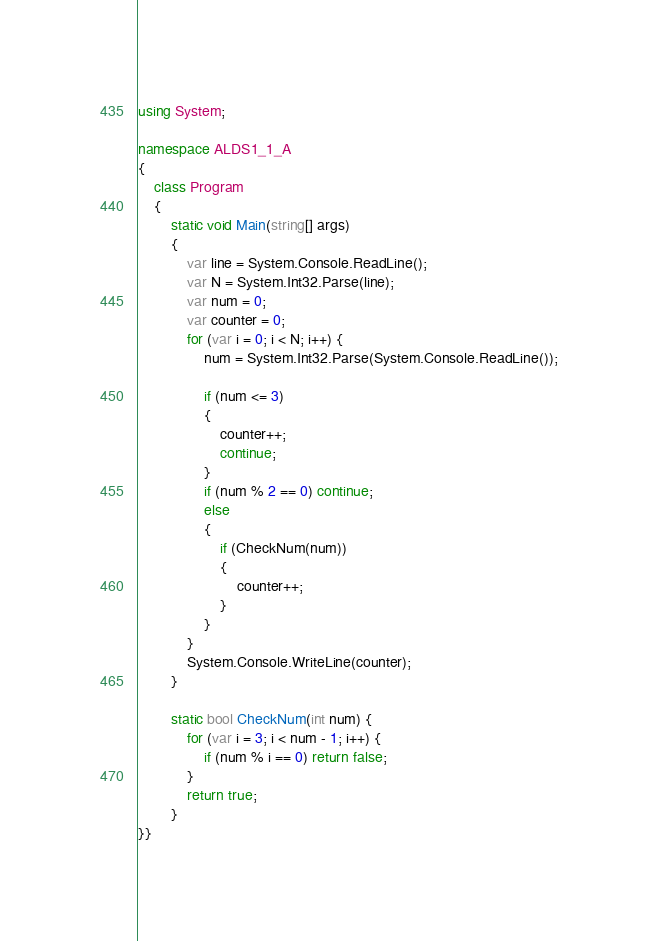Convert code to text. <code><loc_0><loc_0><loc_500><loc_500><_C#_>using System;

namespace ALDS1_1_A
{
    class Program
    {
        static void Main(string[] args)
        {
            var line = System.Console.ReadLine();
            var N = System.Int32.Parse(line);
            var num = 0;
            var counter = 0;
            for (var i = 0; i < N; i++) {
                num = System.Int32.Parse(System.Console.ReadLine());

                if (num <= 3)
                {
                    counter++;
                    continue;
                }
                if (num % 2 == 0) continue;
                else
                {
                    if (CheckNum(num))
                    {
                        counter++;
                    }
                }
            }
            System.Console.WriteLine(counter);
        }

        static bool CheckNum(int num) {
            for (var i = 3; i < num - 1; i++) {
                if (num % i == 0) return false;
            }
            return true;
        }
}}</code> 